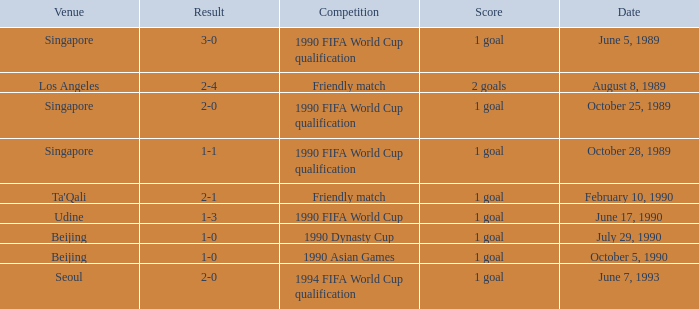What was the venue where the result was 2-1? Ta'Qali. 